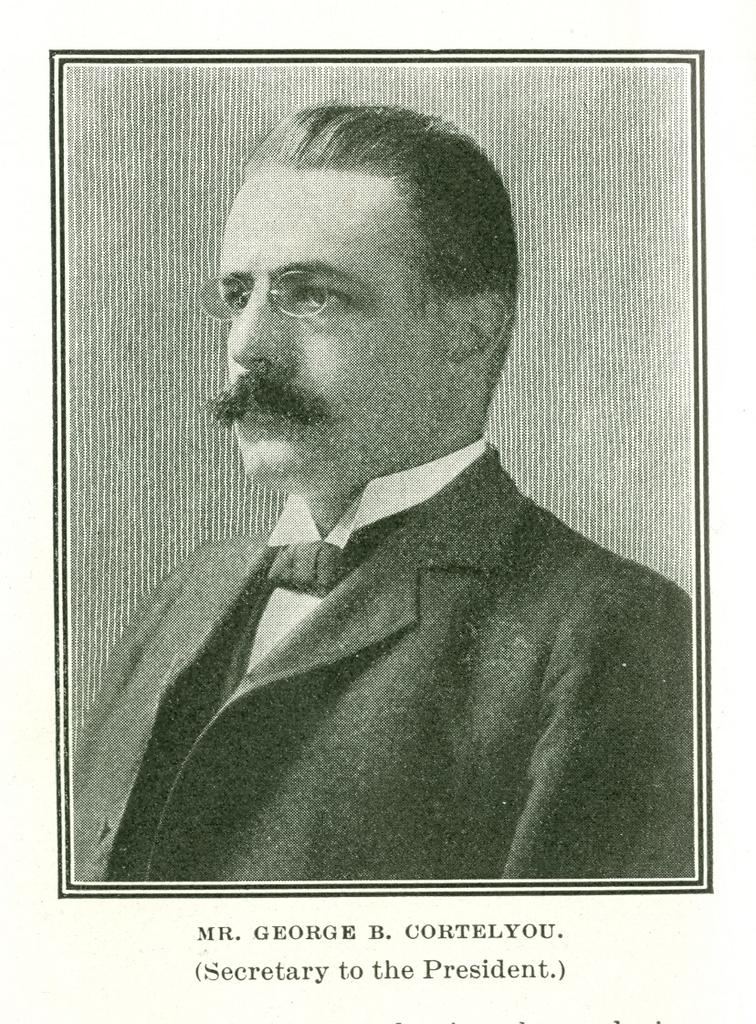What is the main subject of the image? There is a photograph of a man in the image. What is the man wearing in the image? The man is wearing a jacket. Is there any text present in the image? Yes, there is text at the bottom of the image. How does the man in the image react to the coughing sound in the background? There is no coughing sound present in the image, as it only features a photograph of a man wearing a jacket with text at the bottom. 